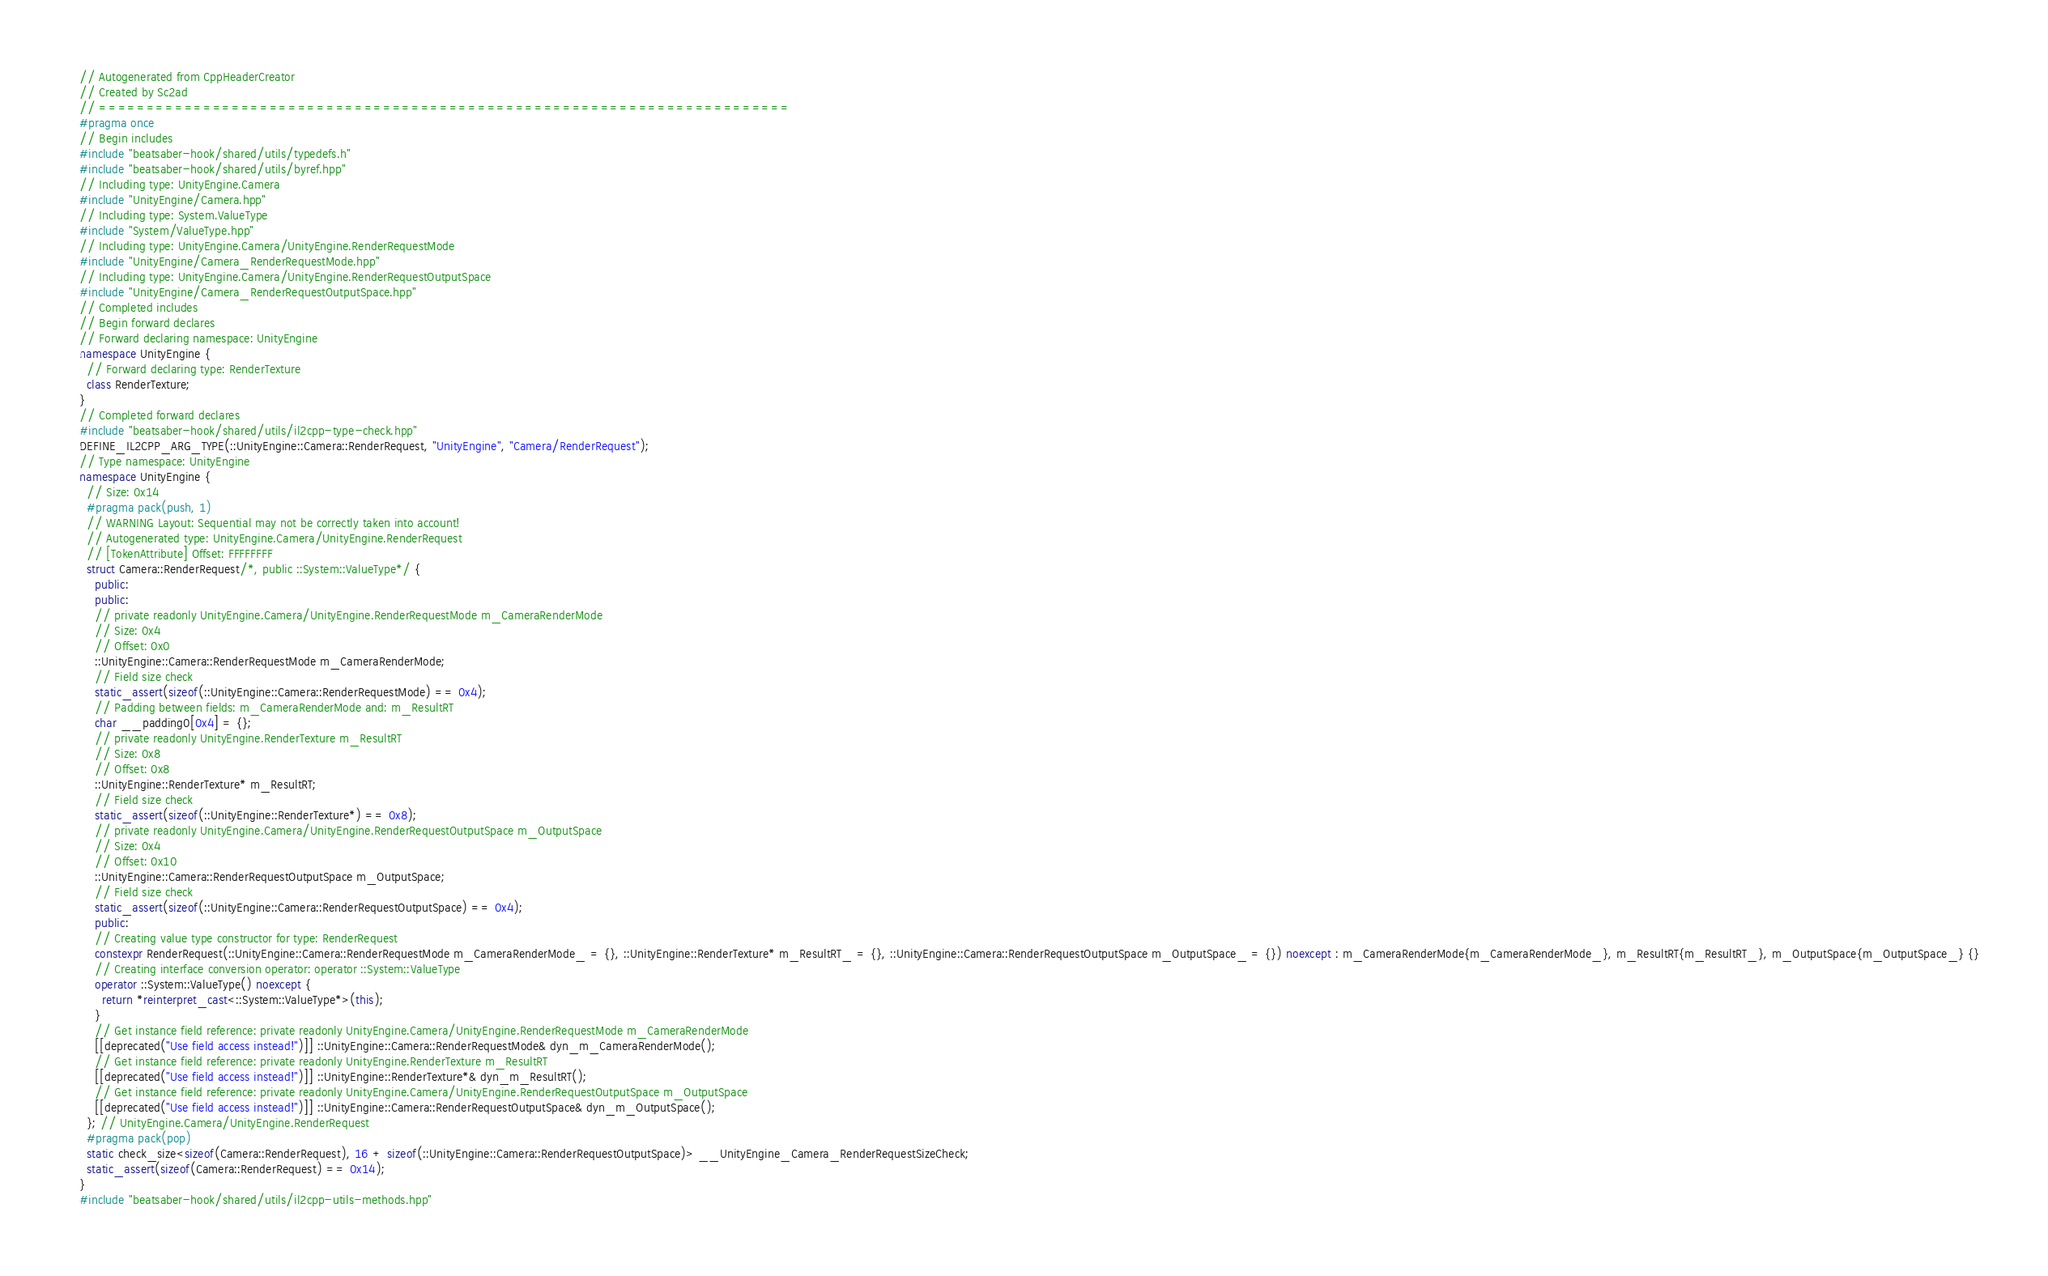Convert code to text. <code><loc_0><loc_0><loc_500><loc_500><_C++_>// Autogenerated from CppHeaderCreator
// Created by Sc2ad
// =========================================================================
#pragma once
// Begin includes
#include "beatsaber-hook/shared/utils/typedefs.h"
#include "beatsaber-hook/shared/utils/byref.hpp"
// Including type: UnityEngine.Camera
#include "UnityEngine/Camera.hpp"
// Including type: System.ValueType
#include "System/ValueType.hpp"
// Including type: UnityEngine.Camera/UnityEngine.RenderRequestMode
#include "UnityEngine/Camera_RenderRequestMode.hpp"
// Including type: UnityEngine.Camera/UnityEngine.RenderRequestOutputSpace
#include "UnityEngine/Camera_RenderRequestOutputSpace.hpp"
// Completed includes
// Begin forward declares
// Forward declaring namespace: UnityEngine
namespace UnityEngine {
  // Forward declaring type: RenderTexture
  class RenderTexture;
}
// Completed forward declares
#include "beatsaber-hook/shared/utils/il2cpp-type-check.hpp"
DEFINE_IL2CPP_ARG_TYPE(::UnityEngine::Camera::RenderRequest, "UnityEngine", "Camera/RenderRequest");
// Type namespace: UnityEngine
namespace UnityEngine {
  // Size: 0x14
  #pragma pack(push, 1)
  // WARNING Layout: Sequential may not be correctly taken into account!
  // Autogenerated type: UnityEngine.Camera/UnityEngine.RenderRequest
  // [TokenAttribute] Offset: FFFFFFFF
  struct Camera::RenderRequest/*, public ::System::ValueType*/ {
    public:
    public:
    // private readonly UnityEngine.Camera/UnityEngine.RenderRequestMode m_CameraRenderMode
    // Size: 0x4
    // Offset: 0x0
    ::UnityEngine::Camera::RenderRequestMode m_CameraRenderMode;
    // Field size check
    static_assert(sizeof(::UnityEngine::Camera::RenderRequestMode) == 0x4);
    // Padding between fields: m_CameraRenderMode and: m_ResultRT
    char __padding0[0x4] = {};
    // private readonly UnityEngine.RenderTexture m_ResultRT
    // Size: 0x8
    // Offset: 0x8
    ::UnityEngine::RenderTexture* m_ResultRT;
    // Field size check
    static_assert(sizeof(::UnityEngine::RenderTexture*) == 0x8);
    // private readonly UnityEngine.Camera/UnityEngine.RenderRequestOutputSpace m_OutputSpace
    // Size: 0x4
    // Offset: 0x10
    ::UnityEngine::Camera::RenderRequestOutputSpace m_OutputSpace;
    // Field size check
    static_assert(sizeof(::UnityEngine::Camera::RenderRequestOutputSpace) == 0x4);
    public:
    // Creating value type constructor for type: RenderRequest
    constexpr RenderRequest(::UnityEngine::Camera::RenderRequestMode m_CameraRenderMode_ = {}, ::UnityEngine::RenderTexture* m_ResultRT_ = {}, ::UnityEngine::Camera::RenderRequestOutputSpace m_OutputSpace_ = {}) noexcept : m_CameraRenderMode{m_CameraRenderMode_}, m_ResultRT{m_ResultRT_}, m_OutputSpace{m_OutputSpace_} {}
    // Creating interface conversion operator: operator ::System::ValueType
    operator ::System::ValueType() noexcept {
      return *reinterpret_cast<::System::ValueType*>(this);
    }
    // Get instance field reference: private readonly UnityEngine.Camera/UnityEngine.RenderRequestMode m_CameraRenderMode
    [[deprecated("Use field access instead!")]] ::UnityEngine::Camera::RenderRequestMode& dyn_m_CameraRenderMode();
    // Get instance field reference: private readonly UnityEngine.RenderTexture m_ResultRT
    [[deprecated("Use field access instead!")]] ::UnityEngine::RenderTexture*& dyn_m_ResultRT();
    // Get instance field reference: private readonly UnityEngine.Camera/UnityEngine.RenderRequestOutputSpace m_OutputSpace
    [[deprecated("Use field access instead!")]] ::UnityEngine::Camera::RenderRequestOutputSpace& dyn_m_OutputSpace();
  }; // UnityEngine.Camera/UnityEngine.RenderRequest
  #pragma pack(pop)
  static check_size<sizeof(Camera::RenderRequest), 16 + sizeof(::UnityEngine::Camera::RenderRequestOutputSpace)> __UnityEngine_Camera_RenderRequestSizeCheck;
  static_assert(sizeof(Camera::RenderRequest) == 0x14);
}
#include "beatsaber-hook/shared/utils/il2cpp-utils-methods.hpp"
</code> 